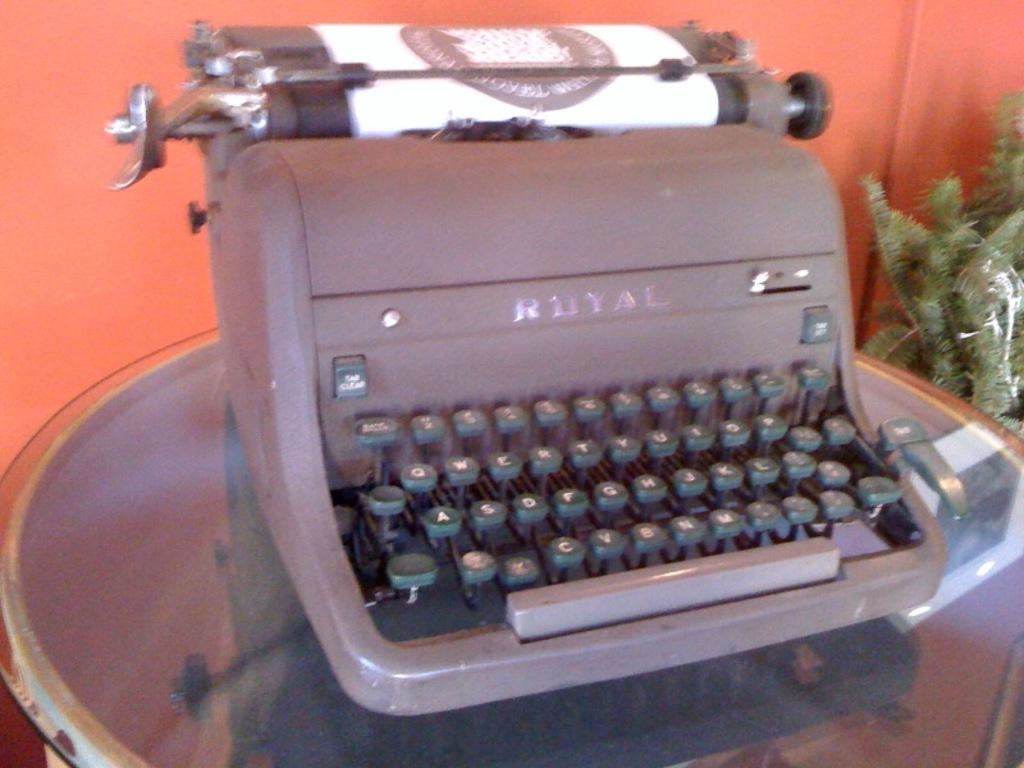What is the bottom left key on the type writer?
Ensure brevity in your answer.  Z. What is the brand name of the typewriter?
Offer a terse response. Royal. 